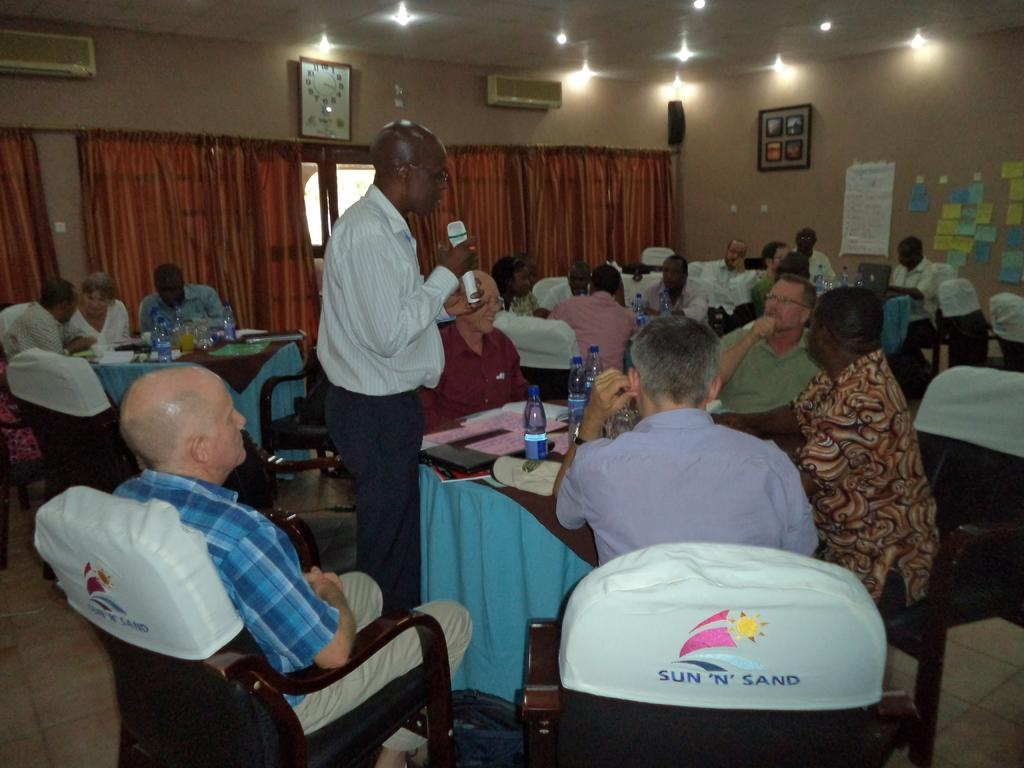How many people are in the image? There is a group of people in the image. What are the people doing in the image? The people are seated on chairs. Is there anyone standing in the image? Yes, there is a man standing in the image. What is the man doing in the image? The man is speaking with the help of a microphone. What type of water can be seen in the image? There is no water present in the image. What game are the people playing in the image? There is no game being played in the image; the people are seated and a man is speaking with a microphone. 